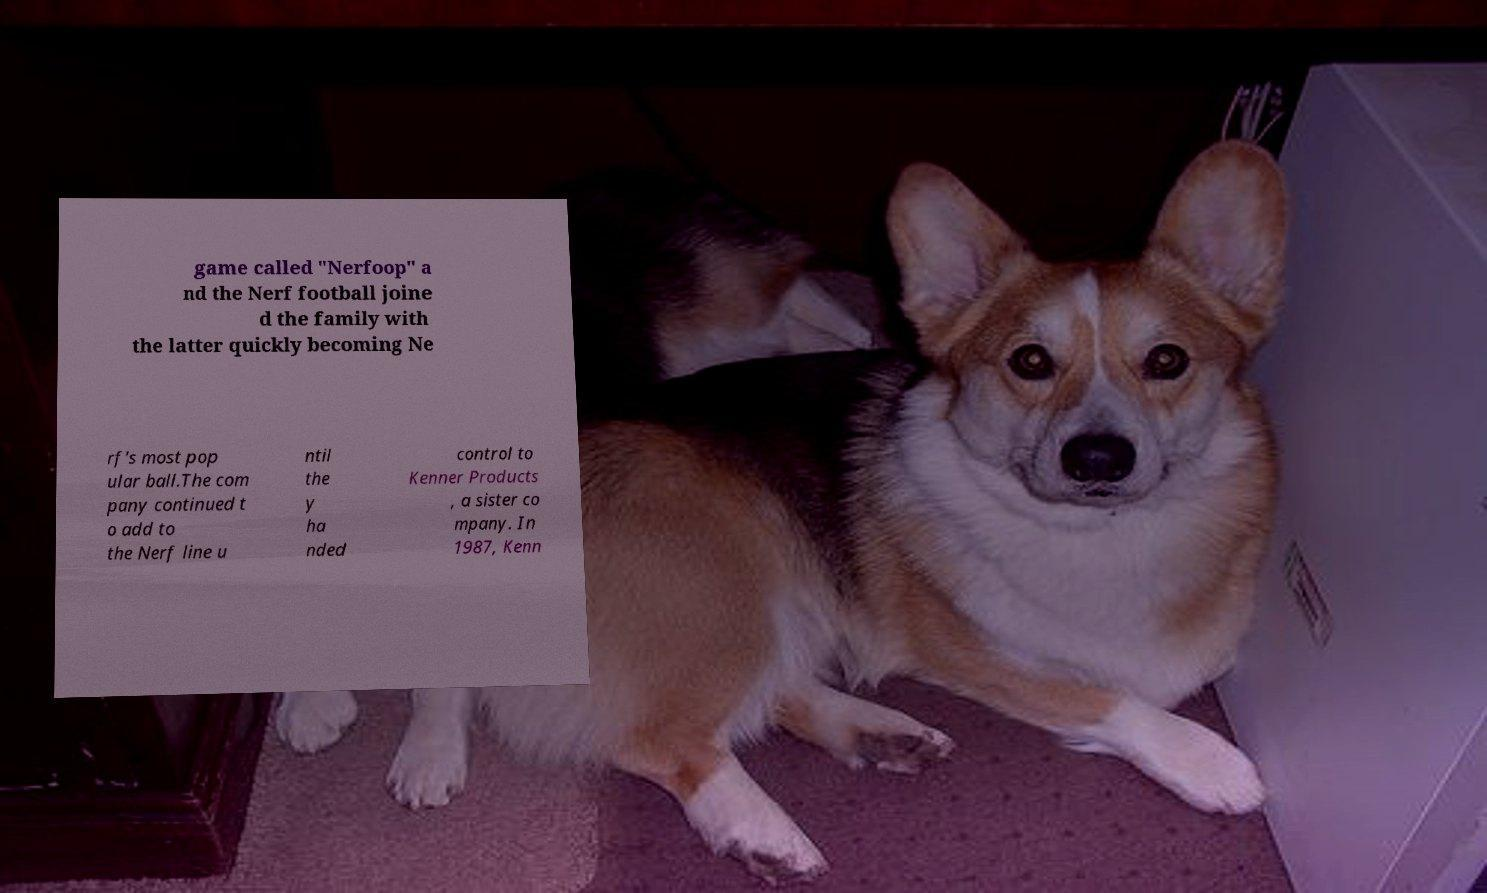Could you assist in decoding the text presented in this image and type it out clearly? game called "Nerfoop" a nd the Nerf football joine d the family with the latter quickly becoming Ne rf's most pop ular ball.The com pany continued t o add to the Nerf line u ntil the y ha nded control to Kenner Products , a sister co mpany. In 1987, Kenn 